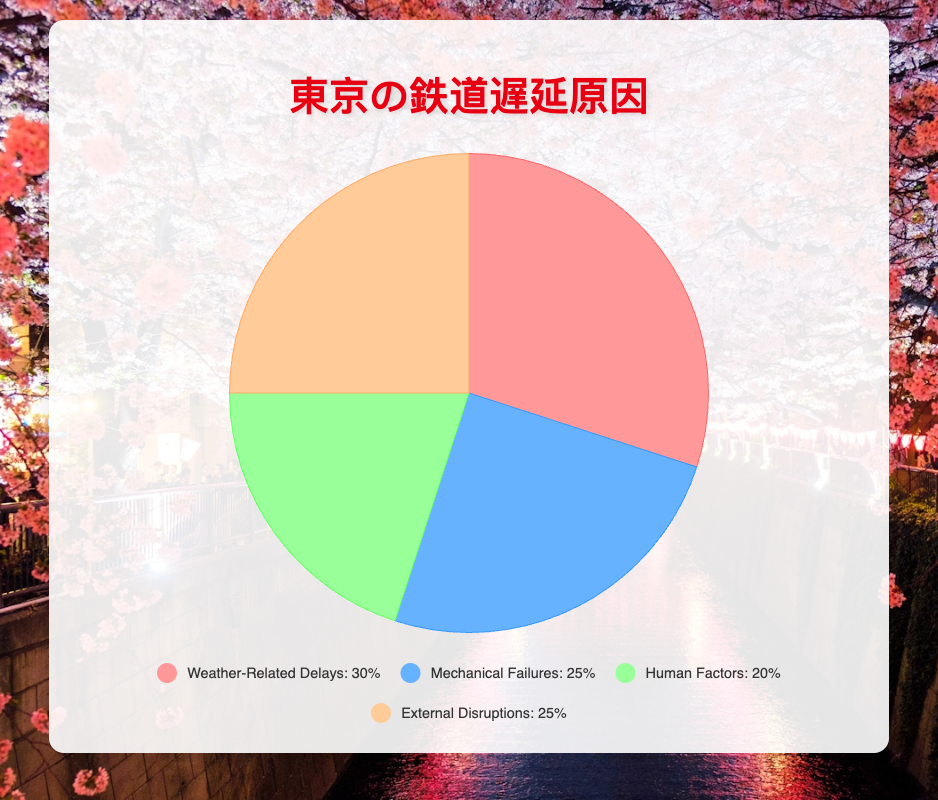Which cause accounts for the largest percentage of train delays in Tokyo's railway network? The figure shows each cause and its percentage. "Weather-Related Delays" has the highest percentage at 30%.
Answer: Weather-Related Delays Which two causes have the same percentage of train delays? Observing the figure, "Mechanical Failures" and "External Disruptions" both have a percentage of 25%.
Answer: Mechanical Failures and External Disruptions What is the combined percentage of delays caused by Mechanical Failures and Human Factors? The figure indicates 25% for Mechanical Failures and 20% for Human Factors. Combined, they account for 25% + 20% = 45%.
Answer: 45% Which cause has the smallest share in train delays? "Human Factors" has the smallest share with 20%, based on the figure.
Answer: Human Factors What is the percentage difference between Weather-Related Delays and Human Factors? "Weather-Related Delays" is 30% and "Human Factors" is 20%. The difference is 30% - 20% = 10%.
Answer: 10% If you combine the percentages of Weather-Related Delays and External Disruptions, what fraction of the total delays do they represent? "Weather-Related Delays" is 30% and "External Disruptions" is 25%. Combined, they are 30% + 25% = 55%, which is 55/100 or 11/20 as a fraction.
Answer: 11/20 Among the causes listed, which one is represented by the blue color? The figure uses blue to represent "Mechanical Failures".
Answer: Mechanical Failures How much more do Weather-Related Delays contribute to train delays compared to Human Factors? Weather-Related Delays contribute 30%, and Human Factors contribute 20%. The difference is 30% - 20% = 10%.
Answer: 10% What proportion of delays are due to External Disruptions and can be visually identified from the chart? External Disruptions account for 25%, as indicated by the color and legend in the figure.
Answer: 25% Calculate the average percentage of delays for all the causes. Sum the percentages: 30% (Weather-Related Delays) + 25% (Mechanical Failures) + 20% (Human Factors) + 25% (External Disruptions) = 100%. Average = 100% / 4 causes = 25%.
Answer: 25% 